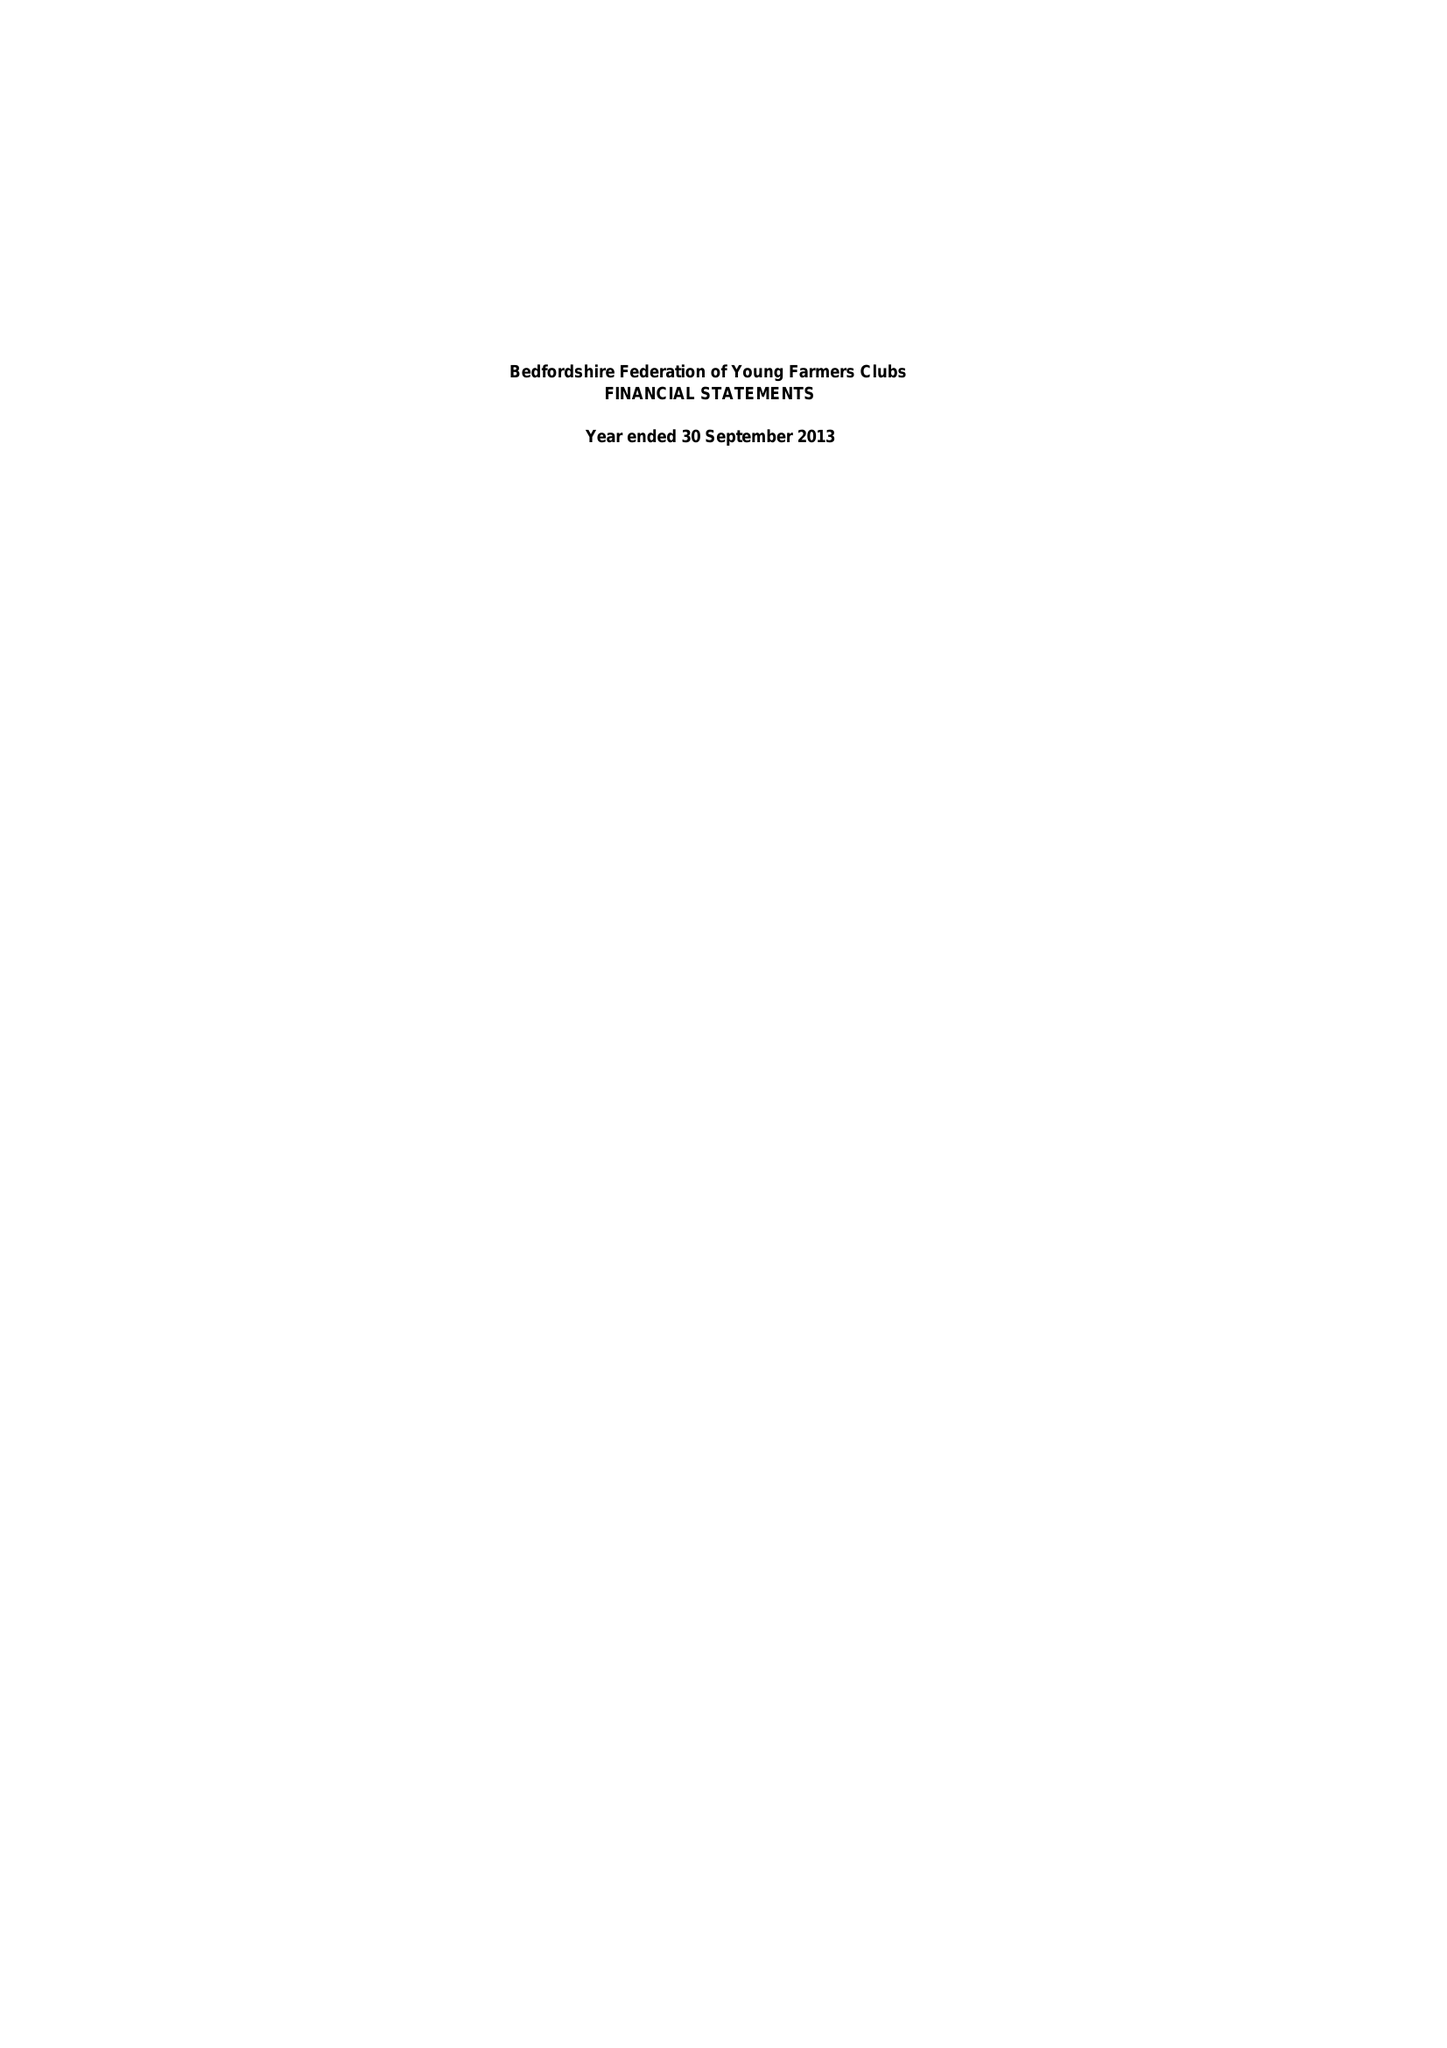What is the value for the charity_number?
Answer the question using a single word or phrase. None 